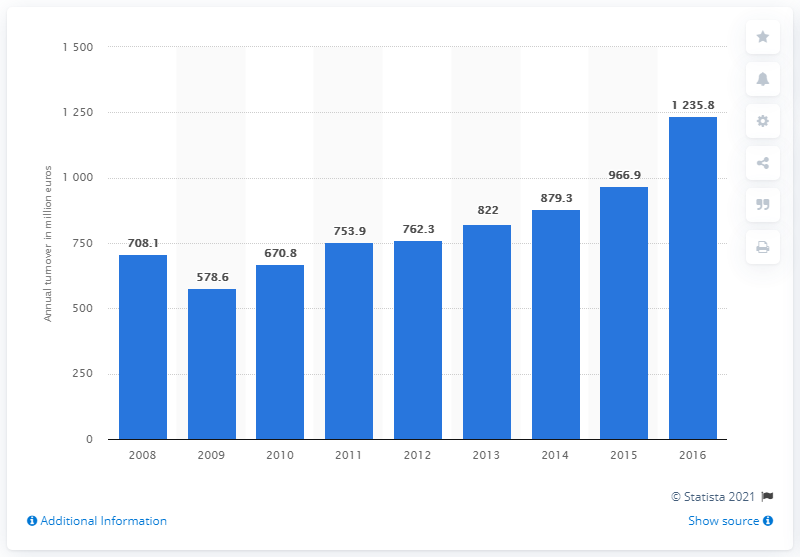Indicate a few pertinent items in this graphic. In 2016, the turnover of Romania's paper manufacturing industry was 1235.8.. 